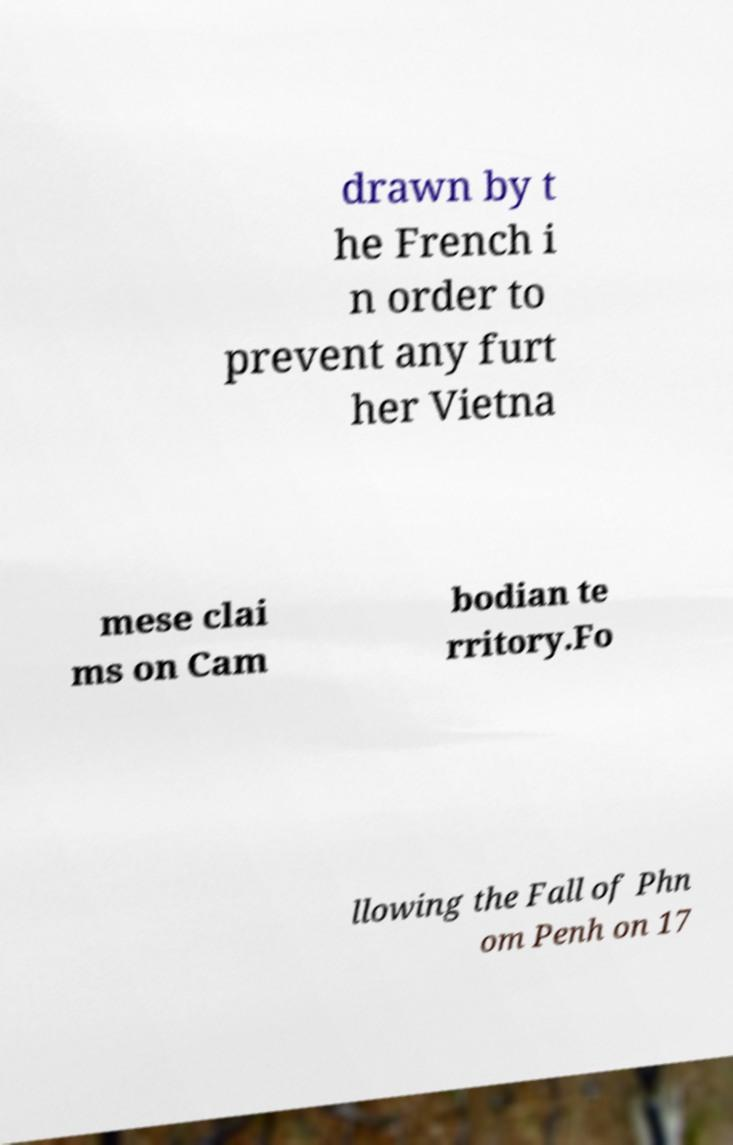Can you read and provide the text displayed in the image?This photo seems to have some interesting text. Can you extract and type it out for me? drawn by t he French i n order to prevent any furt her Vietna mese clai ms on Cam bodian te rritory.Fo llowing the Fall of Phn om Penh on 17 